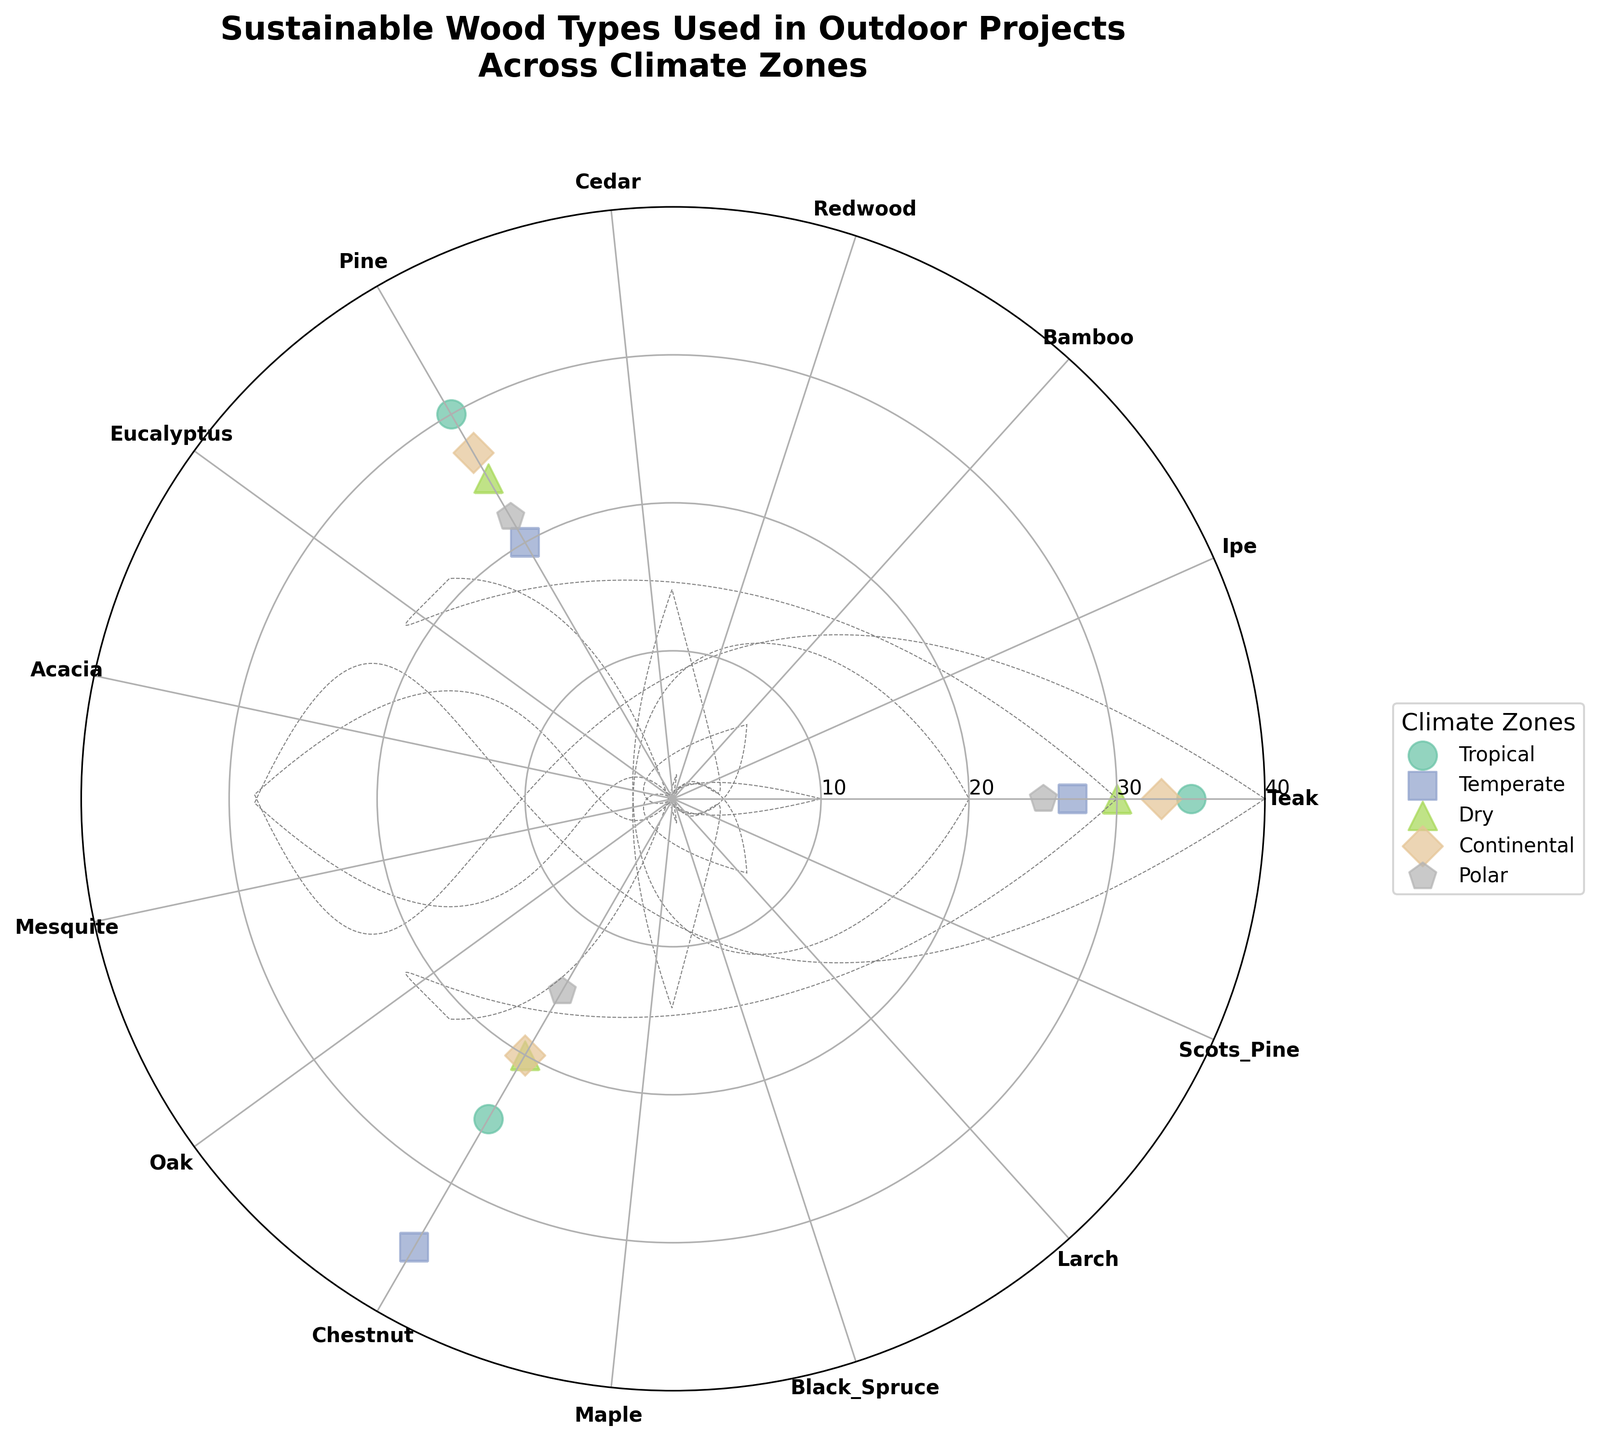What wood types are used in the Polar climate zone? The Polar scatter points are marked next to their wood type labels on the polar chart.
Answer: Black Spruce, Larch, Scots Pine What's the range of frequencies for the different sustainable wood types in outdoor projects within the Temperate climate zone? In the Temperate zone, the frequencies of different wood types can be observed by looking at the scatter points: Redwood (27), Cedar (20), Pine (35). The range is the difference between the highest and lowest frequencies, i.e. 35 - 20.
Answer: 15 Which climate zone uses Ipe wood most frequently? Checking the scatter points for Ipe, which is represented within the Tropical zone with a frequency of 30 as shown on the polar chart, and verifying no other zone uses Ipe.
Answer: Tropical How does the frequency of Acacia in the Dry zone compare to the frequency of Chestnut in the Continental zone? Observing that the scatter points for Acacia in the Dry zone have a frequency of 25, and Chestnut in the Continental zone has a frequency of 27, it becomes clear that Acacia is used less frequently than Chestnut.
Answer: Acacia less than Chestnut What is the average frequency of sustainable wood types used in the Tropical climate zone? Summing the frequencies for wood types in the Tropical zone (Teak: 35, Ipe: 30, Bamboo: 25) and dividing the total by the number of wood types (3). (35 + 30 + 25) / 3 = 90 / 3 = 30.
Answer: 30 